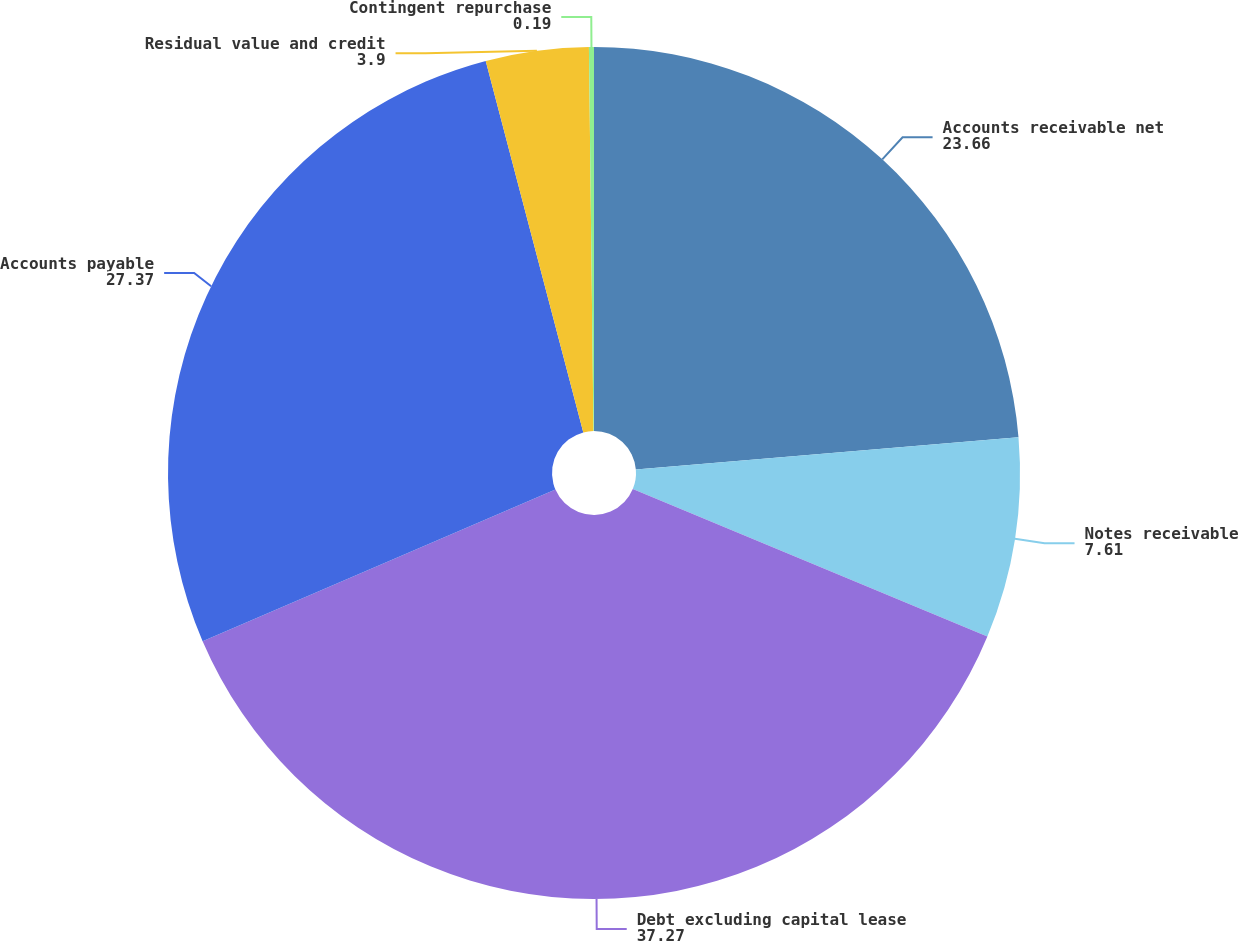<chart> <loc_0><loc_0><loc_500><loc_500><pie_chart><fcel>Accounts receivable net<fcel>Notes receivable<fcel>Debt excluding capital lease<fcel>Accounts payable<fcel>Residual value and credit<fcel>Contingent repurchase<nl><fcel>23.66%<fcel>7.61%<fcel>37.27%<fcel>27.37%<fcel>3.9%<fcel>0.19%<nl></chart> 